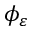Convert formula to latex. <formula><loc_0><loc_0><loc_500><loc_500>\phi _ { \varepsilon }</formula> 